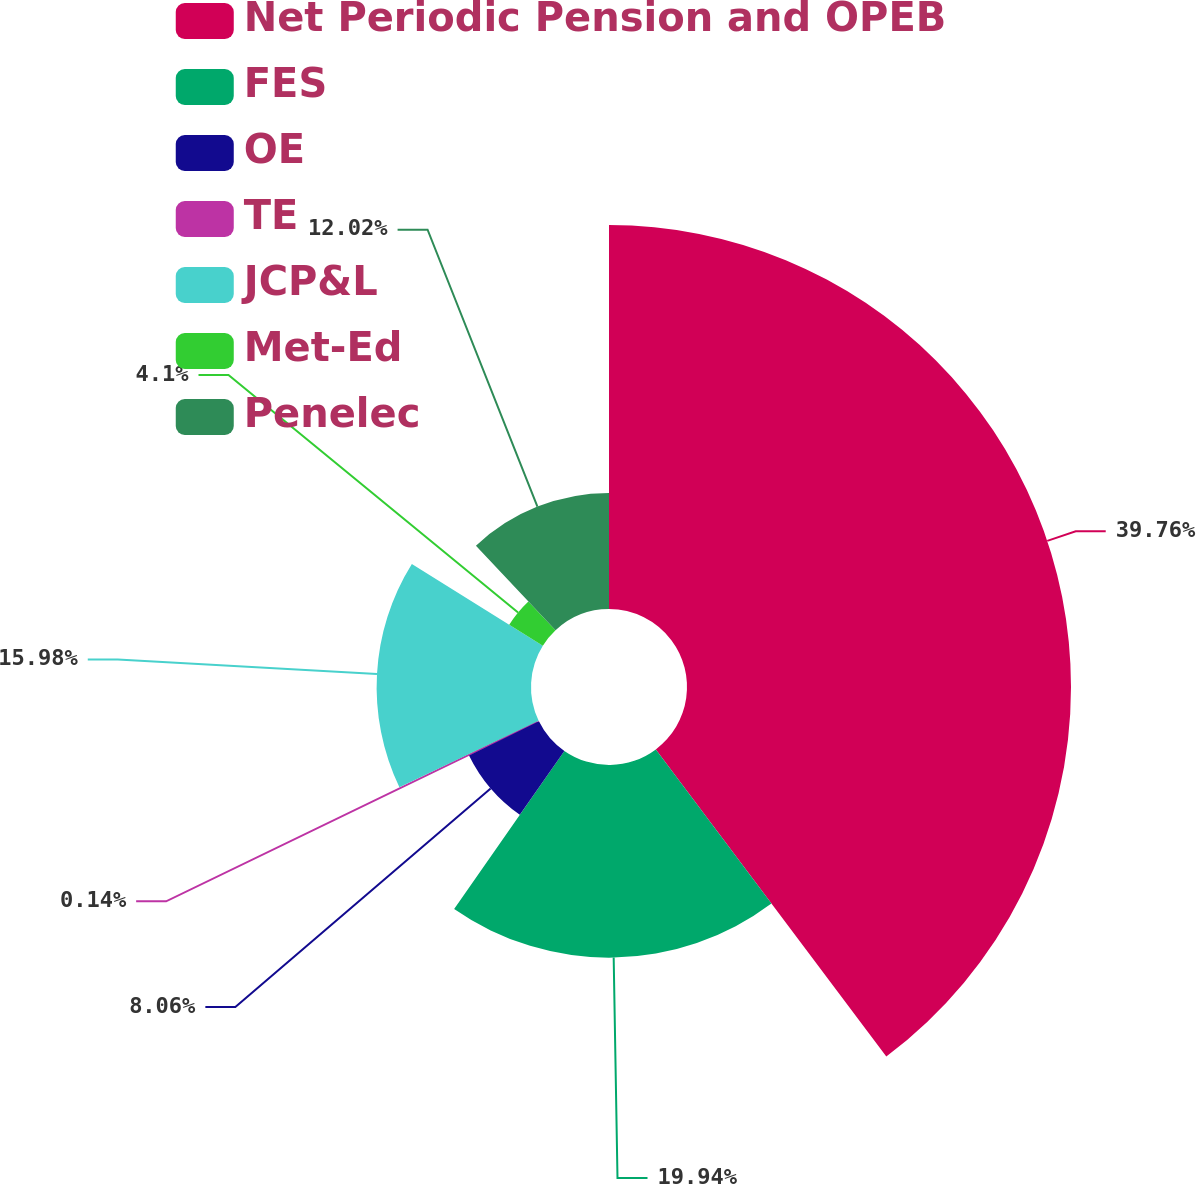<chart> <loc_0><loc_0><loc_500><loc_500><pie_chart><fcel>Net Periodic Pension and OPEB<fcel>FES<fcel>OE<fcel>TE<fcel>JCP&L<fcel>Met-Ed<fcel>Penelec<nl><fcel>39.75%<fcel>19.94%<fcel>8.06%<fcel>0.14%<fcel>15.98%<fcel>4.1%<fcel>12.02%<nl></chart> 